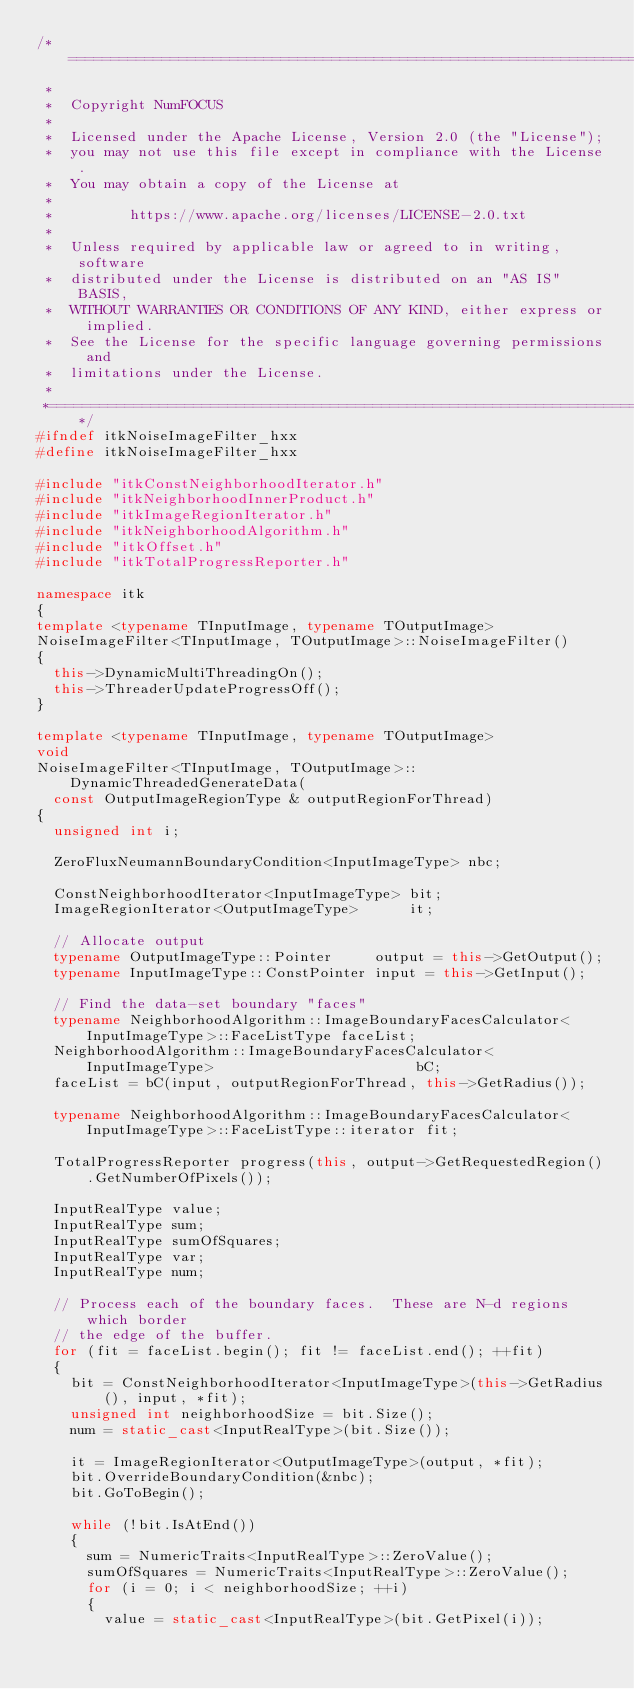<code> <loc_0><loc_0><loc_500><loc_500><_C++_>/*=========================================================================
 *
 *  Copyright NumFOCUS
 *
 *  Licensed under the Apache License, Version 2.0 (the "License");
 *  you may not use this file except in compliance with the License.
 *  You may obtain a copy of the License at
 *
 *         https://www.apache.org/licenses/LICENSE-2.0.txt
 *
 *  Unless required by applicable law or agreed to in writing, software
 *  distributed under the License is distributed on an "AS IS" BASIS,
 *  WITHOUT WARRANTIES OR CONDITIONS OF ANY KIND, either express or implied.
 *  See the License for the specific language governing permissions and
 *  limitations under the License.
 *
 *=========================================================================*/
#ifndef itkNoiseImageFilter_hxx
#define itkNoiseImageFilter_hxx

#include "itkConstNeighborhoodIterator.h"
#include "itkNeighborhoodInnerProduct.h"
#include "itkImageRegionIterator.h"
#include "itkNeighborhoodAlgorithm.h"
#include "itkOffset.h"
#include "itkTotalProgressReporter.h"

namespace itk
{
template <typename TInputImage, typename TOutputImage>
NoiseImageFilter<TInputImage, TOutputImage>::NoiseImageFilter()
{
  this->DynamicMultiThreadingOn();
  this->ThreaderUpdateProgressOff();
}

template <typename TInputImage, typename TOutputImage>
void
NoiseImageFilter<TInputImage, TOutputImage>::DynamicThreadedGenerateData(
  const OutputImageRegionType & outputRegionForThread)
{
  unsigned int i;

  ZeroFluxNeumannBoundaryCondition<InputImageType> nbc;

  ConstNeighborhoodIterator<InputImageType> bit;
  ImageRegionIterator<OutputImageType>      it;

  // Allocate output
  typename OutputImageType::Pointer     output = this->GetOutput();
  typename InputImageType::ConstPointer input = this->GetInput();

  // Find the data-set boundary "faces"
  typename NeighborhoodAlgorithm::ImageBoundaryFacesCalculator<InputImageType>::FaceListType faceList;
  NeighborhoodAlgorithm::ImageBoundaryFacesCalculator<InputImageType>                        bC;
  faceList = bC(input, outputRegionForThread, this->GetRadius());

  typename NeighborhoodAlgorithm::ImageBoundaryFacesCalculator<InputImageType>::FaceListType::iterator fit;

  TotalProgressReporter progress(this, output->GetRequestedRegion().GetNumberOfPixels());

  InputRealType value;
  InputRealType sum;
  InputRealType sumOfSquares;
  InputRealType var;
  InputRealType num;

  // Process each of the boundary faces.  These are N-d regions which border
  // the edge of the buffer.
  for (fit = faceList.begin(); fit != faceList.end(); ++fit)
  {
    bit = ConstNeighborhoodIterator<InputImageType>(this->GetRadius(), input, *fit);
    unsigned int neighborhoodSize = bit.Size();
    num = static_cast<InputRealType>(bit.Size());

    it = ImageRegionIterator<OutputImageType>(output, *fit);
    bit.OverrideBoundaryCondition(&nbc);
    bit.GoToBegin();

    while (!bit.IsAtEnd())
    {
      sum = NumericTraits<InputRealType>::ZeroValue();
      sumOfSquares = NumericTraits<InputRealType>::ZeroValue();
      for (i = 0; i < neighborhoodSize; ++i)
      {
        value = static_cast<InputRealType>(bit.GetPixel(i));</code> 